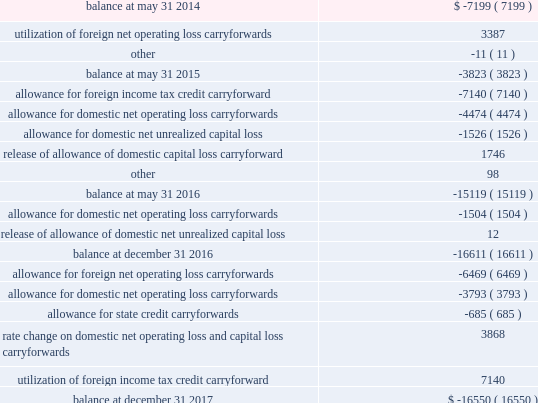A valuation allowance is provided against deferred tax assets when it is more likely than not that some portion or all of the deferred tax assets will not be realized .
Changes to our valuation allowance during the year ended december 31 , 2017 , the 2016 fiscal transition period and the years ended may 31 , 2016 and 2015 are summarized below ( in thousands ) : .
The increase in the valuation allowance related to net operating loss carryforwards of $ 10.3 million for the year ended december 31 , 2017 relates primarily to carryforward assets recorded as part of the acquisition of active network .
The increase in the valuation allowance related to domestic net operating loss carryforwards of $ 1.5 million and $ 4.5 million for the 2016 fiscal transition period and the year ended may 31 , 2016 , respectively , relates to acquired carryforwards from the merger with heartland .
Foreign net operating loss carryforwards of $ 43.2 million and domestic net operating loss carryforwards of $ 28.9 million at december 31 , 2017 will expire between december 31 , 2026 and december 31 , 2037 if not utilized .
We conduct business globally and file income tax returns in the domestic federal jurisdiction and various state and foreign jurisdictions .
In the normal course of business , we are subject to examination by taxing authorities around the world .
We are no longer subjected to state income tax examinations for years ended on or before may 31 , 2008 , u.s .
Federal income tax examinations for years ended on or before december 31 , 2013 and u.k .
Federal income tax examinations for years ended on or before may 31 , 2014 .
88 2013 global payments inc .
| 2017 form 10-k annual report .
What was the net change in the valuation allowance in thousands between 2014 and 2015? 
Computations: (-3823 - -7199)
Answer: 3376.0. 